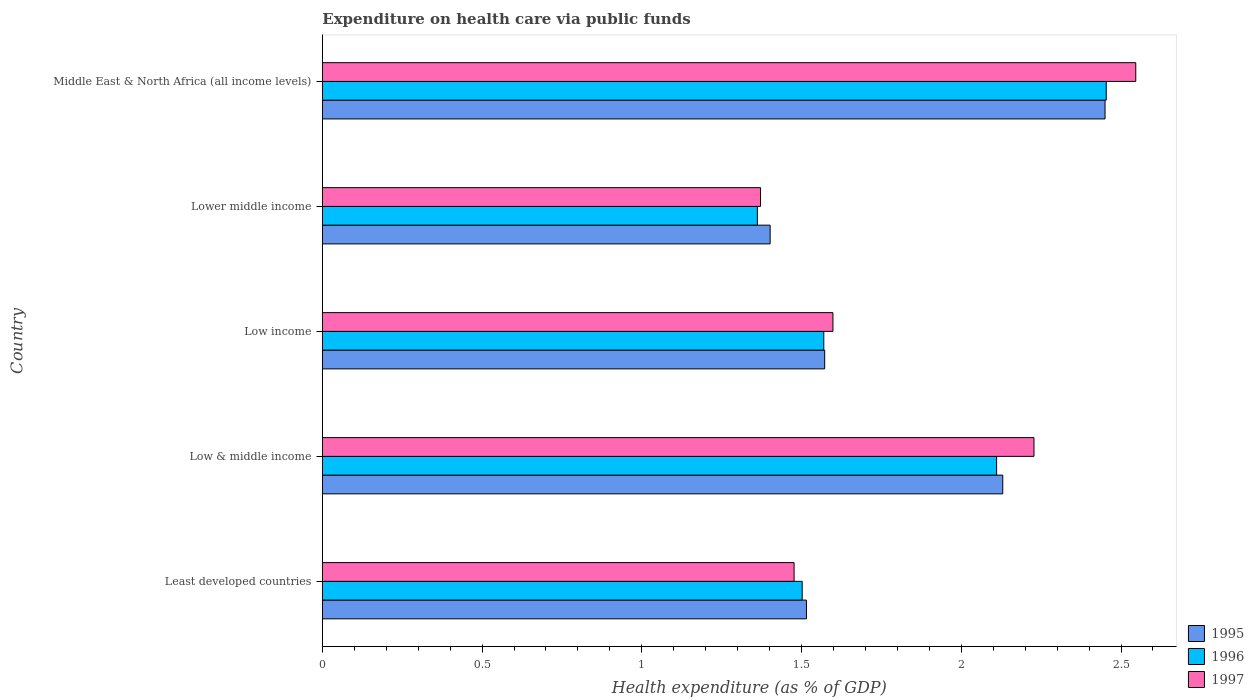Are the number of bars per tick equal to the number of legend labels?
Offer a very short reply. Yes. Are the number of bars on each tick of the Y-axis equal?
Provide a short and direct response. Yes. How many bars are there on the 3rd tick from the bottom?
Provide a succinct answer. 3. What is the label of the 2nd group of bars from the top?
Provide a short and direct response. Lower middle income. What is the expenditure made on health care in 1995 in Middle East & North Africa (all income levels)?
Give a very brief answer. 2.45. Across all countries, what is the maximum expenditure made on health care in 1995?
Your answer should be compact. 2.45. Across all countries, what is the minimum expenditure made on health care in 1996?
Your response must be concise. 1.36. In which country was the expenditure made on health care in 1995 maximum?
Give a very brief answer. Middle East & North Africa (all income levels). In which country was the expenditure made on health care in 1995 minimum?
Your answer should be very brief. Lower middle income. What is the total expenditure made on health care in 1995 in the graph?
Offer a terse response. 9.07. What is the difference between the expenditure made on health care in 1996 in Low income and that in Middle East & North Africa (all income levels)?
Offer a terse response. -0.88. What is the difference between the expenditure made on health care in 1996 in Lower middle income and the expenditure made on health care in 1995 in Least developed countries?
Provide a short and direct response. -0.15. What is the average expenditure made on health care in 1996 per country?
Keep it short and to the point. 1.8. What is the difference between the expenditure made on health care in 1996 and expenditure made on health care in 1995 in Low & middle income?
Provide a short and direct response. -0.02. What is the ratio of the expenditure made on health care in 1995 in Least developed countries to that in Middle East & North Africa (all income levels)?
Ensure brevity in your answer.  0.62. Is the expenditure made on health care in 1997 in Least developed countries less than that in Low income?
Keep it short and to the point. Yes. What is the difference between the highest and the second highest expenditure made on health care in 1996?
Your answer should be compact. 0.34. What is the difference between the highest and the lowest expenditure made on health care in 1997?
Your answer should be very brief. 1.17. In how many countries, is the expenditure made on health care in 1995 greater than the average expenditure made on health care in 1995 taken over all countries?
Your response must be concise. 2. What does the 3rd bar from the top in Least developed countries represents?
Offer a terse response. 1995. What does the 3rd bar from the bottom in Low & middle income represents?
Your answer should be compact. 1997. Is it the case that in every country, the sum of the expenditure made on health care in 1996 and expenditure made on health care in 1995 is greater than the expenditure made on health care in 1997?
Provide a succinct answer. Yes. How many bars are there?
Keep it short and to the point. 15. Are all the bars in the graph horizontal?
Ensure brevity in your answer.  Yes. How many countries are there in the graph?
Your answer should be compact. 5. Are the values on the major ticks of X-axis written in scientific E-notation?
Your answer should be compact. No. Does the graph contain grids?
Offer a terse response. No. How are the legend labels stacked?
Your answer should be very brief. Vertical. What is the title of the graph?
Your answer should be compact. Expenditure on health care via public funds. What is the label or title of the X-axis?
Your answer should be very brief. Health expenditure (as % of GDP). What is the label or title of the Y-axis?
Provide a succinct answer. Country. What is the Health expenditure (as % of GDP) in 1995 in Least developed countries?
Offer a terse response. 1.52. What is the Health expenditure (as % of GDP) of 1996 in Least developed countries?
Your answer should be compact. 1.5. What is the Health expenditure (as % of GDP) of 1997 in Least developed countries?
Provide a succinct answer. 1.48. What is the Health expenditure (as % of GDP) in 1995 in Low & middle income?
Provide a short and direct response. 2.13. What is the Health expenditure (as % of GDP) in 1996 in Low & middle income?
Ensure brevity in your answer.  2.11. What is the Health expenditure (as % of GDP) of 1997 in Low & middle income?
Your answer should be very brief. 2.23. What is the Health expenditure (as % of GDP) of 1995 in Low income?
Give a very brief answer. 1.57. What is the Health expenditure (as % of GDP) of 1996 in Low income?
Offer a terse response. 1.57. What is the Health expenditure (as % of GDP) of 1997 in Low income?
Provide a succinct answer. 1.6. What is the Health expenditure (as % of GDP) of 1995 in Lower middle income?
Your response must be concise. 1.4. What is the Health expenditure (as % of GDP) of 1996 in Lower middle income?
Ensure brevity in your answer.  1.36. What is the Health expenditure (as % of GDP) of 1997 in Lower middle income?
Give a very brief answer. 1.37. What is the Health expenditure (as % of GDP) of 1995 in Middle East & North Africa (all income levels)?
Ensure brevity in your answer.  2.45. What is the Health expenditure (as % of GDP) of 1996 in Middle East & North Africa (all income levels)?
Your answer should be compact. 2.45. What is the Health expenditure (as % of GDP) in 1997 in Middle East & North Africa (all income levels)?
Offer a terse response. 2.55. Across all countries, what is the maximum Health expenditure (as % of GDP) in 1995?
Ensure brevity in your answer.  2.45. Across all countries, what is the maximum Health expenditure (as % of GDP) in 1996?
Your response must be concise. 2.45. Across all countries, what is the maximum Health expenditure (as % of GDP) in 1997?
Provide a succinct answer. 2.55. Across all countries, what is the minimum Health expenditure (as % of GDP) of 1995?
Keep it short and to the point. 1.4. Across all countries, what is the minimum Health expenditure (as % of GDP) of 1996?
Offer a terse response. 1.36. Across all countries, what is the minimum Health expenditure (as % of GDP) of 1997?
Your answer should be compact. 1.37. What is the total Health expenditure (as % of GDP) of 1995 in the graph?
Keep it short and to the point. 9.07. What is the total Health expenditure (as % of GDP) of 1996 in the graph?
Your response must be concise. 9. What is the total Health expenditure (as % of GDP) in 1997 in the graph?
Give a very brief answer. 9.22. What is the difference between the Health expenditure (as % of GDP) in 1995 in Least developed countries and that in Low & middle income?
Ensure brevity in your answer.  -0.61. What is the difference between the Health expenditure (as % of GDP) of 1996 in Least developed countries and that in Low & middle income?
Provide a succinct answer. -0.61. What is the difference between the Health expenditure (as % of GDP) of 1997 in Least developed countries and that in Low & middle income?
Ensure brevity in your answer.  -0.75. What is the difference between the Health expenditure (as % of GDP) in 1995 in Least developed countries and that in Low income?
Keep it short and to the point. -0.06. What is the difference between the Health expenditure (as % of GDP) in 1996 in Least developed countries and that in Low income?
Your response must be concise. -0.07. What is the difference between the Health expenditure (as % of GDP) in 1997 in Least developed countries and that in Low income?
Give a very brief answer. -0.12. What is the difference between the Health expenditure (as % of GDP) in 1995 in Least developed countries and that in Lower middle income?
Keep it short and to the point. 0.11. What is the difference between the Health expenditure (as % of GDP) of 1996 in Least developed countries and that in Lower middle income?
Provide a short and direct response. 0.14. What is the difference between the Health expenditure (as % of GDP) in 1997 in Least developed countries and that in Lower middle income?
Give a very brief answer. 0.11. What is the difference between the Health expenditure (as % of GDP) in 1995 in Least developed countries and that in Middle East & North Africa (all income levels)?
Offer a very short reply. -0.93. What is the difference between the Health expenditure (as % of GDP) of 1996 in Least developed countries and that in Middle East & North Africa (all income levels)?
Provide a succinct answer. -0.95. What is the difference between the Health expenditure (as % of GDP) in 1997 in Least developed countries and that in Middle East & North Africa (all income levels)?
Provide a succinct answer. -1.07. What is the difference between the Health expenditure (as % of GDP) in 1995 in Low & middle income and that in Low income?
Offer a terse response. 0.56. What is the difference between the Health expenditure (as % of GDP) of 1996 in Low & middle income and that in Low income?
Offer a terse response. 0.54. What is the difference between the Health expenditure (as % of GDP) of 1997 in Low & middle income and that in Low income?
Your answer should be compact. 0.63. What is the difference between the Health expenditure (as % of GDP) in 1995 in Low & middle income and that in Lower middle income?
Offer a very short reply. 0.73. What is the difference between the Health expenditure (as % of GDP) of 1996 in Low & middle income and that in Lower middle income?
Ensure brevity in your answer.  0.75. What is the difference between the Health expenditure (as % of GDP) in 1997 in Low & middle income and that in Lower middle income?
Provide a short and direct response. 0.86. What is the difference between the Health expenditure (as % of GDP) in 1995 in Low & middle income and that in Middle East & North Africa (all income levels)?
Give a very brief answer. -0.32. What is the difference between the Health expenditure (as % of GDP) of 1996 in Low & middle income and that in Middle East & North Africa (all income levels)?
Offer a terse response. -0.34. What is the difference between the Health expenditure (as % of GDP) of 1997 in Low & middle income and that in Middle East & North Africa (all income levels)?
Your answer should be compact. -0.32. What is the difference between the Health expenditure (as % of GDP) of 1995 in Low income and that in Lower middle income?
Your response must be concise. 0.17. What is the difference between the Health expenditure (as % of GDP) in 1996 in Low income and that in Lower middle income?
Provide a short and direct response. 0.21. What is the difference between the Health expenditure (as % of GDP) of 1997 in Low income and that in Lower middle income?
Provide a short and direct response. 0.23. What is the difference between the Health expenditure (as % of GDP) in 1995 in Low income and that in Middle East & North Africa (all income levels)?
Make the answer very short. -0.88. What is the difference between the Health expenditure (as % of GDP) in 1996 in Low income and that in Middle East & North Africa (all income levels)?
Provide a succinct answer. -0.88. What is the difference between the Health expenditure (as % of GDP) of 1997 in Low income and that in Middle East & North Africa (all income levels)?
Your response must be concise. -0.95. What is the difference between the Health expenditure (as % of GDP) of 1995 in Lower middle income and that in Middle East & North Africa (all income levels)?
Your response must be concise. -1.05. What is the difference between the Health expenditure (as % of GDP) of 1996 in Lower middle income and that in Middle East & North Africa (all income levels)?
Provide a short and direct response. -1.09. What is the difference between the Health expenditure (as % of GDP) of 1997 in Lower middle income and that in Middle East & North Africa (all income levels)?
Provide a short and direct response. -1.17. What is the difference between the Health expenditure (as % of GDP) of 1995 in Least developed countries and the Health expenditure (as % of GDP) of 1996 in Low & middle income?
Your response must be concise. -0.6. What is the difference between the Health expenditure (as % of GDP) of 1995 in Least developed countries and the Health expenditure (as % of GDP) of 1997 in Low & middle income?
Offer a terse response. -0.71. What is the difference between the Health expenditure (as % of GDP) in 1996 in Least developed countries and the Health expenditure (as % of GDP) in 1997 in Low & middle income?
Offer a terse response. -0.73. What is the difference between the Health expenditure (as % of GDP) in 1995 in Least developed countries and the Health expenditure (as % of GDP) in 1996 in Low income?
Your answer should be compact. -0.05. What is the difference between the Health expenditure (as % of GDP) in 1995 in Least developed countries and the Health expenditure (as % of GDP) in 1997 in Low income?
Provide a succinct answer. -0.08. What is the difference between the Health expenditure (as % of GDP) of 1996 in Least developed countries and the Health expenditure (as % of GDP) of 1997 in Low income?
Your answer should be compact. -0.1. What is the difference between the Health expenditure (as % of GDP) of 1995 in Least developed countries and the Health expenditure (as % of GDP) of 1996 in Lower middle income?
Offer a very short reply. 0.15. What is the difference between the Health expenditure (as % of GDP) in 1995 in Least developed countries and the Health expenditure (as % of GDP) in 1997 in Lower middle income?
Your answer should be compact. 0.14. What is the difference between the Health expenditure (as % of GDP) in 1996 in Least developed countries and the Health expenditure (as % of GDP) in 1997 in Lower middle income?
Ensure brevity in your answer.  0.13. What is the difference between the Health expenditure (as % of GDP) in 1995 in Least developed countries and the Health expenditure (as % of GDP) in 1996 in Middle East & North Africa (all income levels)?
Offer a terse response. -0.94. What is the difference between the Health expenditure (as % of GDP) of 1995 in Least developed countries and the Health expenditure (as % of GDP) of 1997 in Middle East & North Africa (all income levels)?
Your answer should be compact. -1.03. What is the difference between the Health expenditure (as % of GDP) in 1996 in Least developed countries and the Health expenditure (as % of GDP) in 1997 in Middle East & North Africa (all income levels)?
Your answer should be very brief. -1.04. What is the difference between the Health expenditure (as % of GDP) in 1995 in Low & middle income and the Health expenditure (as % of GDP) in 1996 in Low income?
Ensure brevity in your answer.  0.56. What is the difference between the Health expenditure (as % of GDP) of 1995 in Low & middle income and the Health expenditure (as % of GDP) of 1997 in Low income?
Ensure brevity in your answer.  0.53. What is the difference between the Health expenditure (as % of GDP) in 1996 in Low & middle income and the Health expenditure (as % of GDP) in 1997 in Low income?
Your response must be concise. 0.51. What is the difference between the Health expenditure (as % of GDP) in 1995 in Low & middle income and the Health expenditure (as % of GDP) in 1996 in Lower middle income?
Provide a succinct answer. 0.77. What is the difference between the Health expenditure (as % of GDP) in 1995 in Low & middle income and the Health expenditure (as % of GDP) in 1997 in Lower middle income?
Ensure brevity in your answer.  0.76. What is the difference between the Health expenditure (as % of GDP) of 1996 in Low & middle income and the Health expenditure (as % of GDP) of 1997 in Lower middle income?
Keep it short and to the point. 0.74. What is the difference between the Health expenditure (as % of GDP) of 1995 in Low & middle income and the Health expenditure (as % of GDP) of 1996 in Middle East & North Africa (all income levels)?
Your answer should be very brief. -0.32. What is the difference between the Health expenditure (as % of GDP) of 1995 in Low & middle income and the Health expenditure (as % of GDP) of 1997 in Middle East & North Africa (all income levels)?
Provide a succinct answer. -0.42. What is the difference between the Health expenditure (as % of GDP) of 1996 in Low & middle income and the Health expenditure (as % of GDP) of 1997 in Middle East & North Africa (all income levels)?
Provide a short and direct response. -0.44. What is the difference between the Health expenditure (as % of GDP) in 1995 in Low income and the Health expenditure (as % of GDP) in 1996 in Lower middle income?
Make the answer very short. 0.21. What is the difference between the Health expenditure (as % of GDP) in 1995 in Low income and the Health expenditure (as % of GDP) in 1997 in Lower middle income?
Offer a very short reply. 0.2. What is the difference between the Health expenditure (as % of GDP) of 1996 in Low income and the Health expenditure (as % of GDP) of 1997 in Lower middle income?
Provide a short and direct response. 0.2. What is the difference between the Health expenditure (as % of GDP) of 1995 in Low income and the Health expenditure (as % of GDP) of 1996 in Middle East & North Africa (all income levels)?
Your answer should be very brief. -0.88. What is the difference between the Health expenditure (as % of GDP) in 1995 in Low income and the Health expenditure (as % of GDP) in 1997 in Middle East & North Africa (all income levels)?
Offer a very short reply. -0.97. What is the difference between the Health expenditure (as % of GDP) of 1996 in Low income and the Health expenditure (as % of GDP) of 1997 in Middle East & North Africa (all income levels)?
Keep it short and to the point. -0.98. What is the difference between the Health expenditure (as % of GDP) of 1995 in Lower middle income and the Health expenditure (as % of GDP) of 1996 in Middle East & North Africa (all income levels)?
Offer a terse response. -1.05. What is the difference between the Health expenditure (as % of GDP) in 1995 in Lower middle income and the Health expenditure (as % of GDP) in 1997 in Middle East & North Africa (all income levels)?
Your response must be concise. -1.14. What is the difference between the Health expenditure (as % of GDP) of 1996 in Lower middle income and the Health expenditure (as % of GDP) of 1997 in Middle East & North Africa (all income levels)?
Your answer should be compact. -1.18. What is the average Health expenditure (as % of GDP) in 1995 per country?
Your answer should be compact. 1.81. What is the average Health expenditure (as % of GDP) of 1996 per country?
Offer a very short reply. 1.8. What is the average Health expenditure (as % of GDP) of 1997 per country?
Offer a very short reply. 1.84. What is the difference between the Health expenditure (as % of GDP) in 1995 and Health expenditure (as % of GDP) in 1996 in Least developed countries?
Ensure brevity in your answer.  0.01. What is the difference between the Health expenditure (as % of GDP) of 1995 and Health expenditure (as % of GDP) of 1997 in Least developed countries?
Provide a succinct answer. 0.04. What is the difference between the Health expenditure (as % of GDP) in 1996 and Health expenditure (as % of GDP) in 1997 in Least developed countries?
Offer a terse response. 0.03. What is the difference between the Health expenditure (as % of GDP) in 1995 and Health expenditure (as % of GDP) in 1996 in Low & middle income?
Ensure brevity in your answer.  0.02. What is the difference between the Health expenditure (as % of GDP) of 1995 and Health expenditure (as % of GDP) of 1997 in Low & middle income?
Provide a succinct answer. -0.1. What is the difference between the Health expenditure (as % of GDP) in 1996 and Health expenditure (as % of GDP) in 1997 in Low & middle income?
Offer a terse response. -0.12. What is the difference between the Health expenditure (as % of GDP) in 1995 and Health expenditure (as % of GDP) in 1996 in Low income?
Offer a terse response. 0. What is the difference between the Health expenditure (as % of GDP) in 1995 and Health expenditure (as % of GDP) in 1997 in Low income?
Give a very brief answer. -0.03. What is the difference between the Health expenditure (as % of GDP) of 1996 and Health expenditure (as % of GDP) of 1997 in Low income?
Keep it short and to the point. -0.03. What is the difference between the Health expenditure (as % of GDP) in 1995 and Health expenditure (as % of GDP) in 1997 in Lower middle income?
Make the answer very short. 0.03. What is the difference between the Health expenditure (as % of GDP) of 1996 and Health expenditure (as % of GDP) of 1997 in Lower middle income?
Offer a very short reply. -0.01. What is the difference between the Health expenditure (as % of GDP) in 1995 and Health expenditure (as % of GDP) in 1996 in Middle East & North Africa (all income levels)?
Your response must be concise. -0. What is the difference between the Health expenditure (as % of GDP) of 1995 and Health expenditure (as % of GDP) of 1997 in Middle East & North Africa (all income levels)?
Your answer should be very brief. -0.1. What is the difference between the Health expenditure (as % of GDP) of 1996 and Health expenditure (as % of GDP) of 1997 in Middle East & North Africa (all income levels)?
Your response must be concise. -0.09. What is the ratio of the Health expenditure (as % of GDP) of 1995 in Least developed countries to that in Low & middle income?
Your response must be concise. 0.71. What is the ratio of the Health expenditure (as % of GDP) in 1996 in Least developed countries to that in Low & middle income?
Provide a succinct answer. 0.71. What is the ratio of the Health expenditure (as % of GDP) in 1997 in Least developed countries to that in Low & middle income?
Provide a short and direct response. 0.66. What is the ratio of the Health expenditure (as % of GDP) of 1995 in Least developed countries to that in Low income?
Offer a terse response. 0.96. What is the ratio of the Health expenditure (as % of GDP) of 1996 in Least developed countries to that in Low income?
Provide a succinct answer. 0.96. What is the ratio of the Health expenditure (as % of GDP) of 1997 in Least developed countries to that in Low income?
Offer a terse response. 0.92. What is the ratio of the Health expenditure (as % of GDP) of 1995 in Least developed countries to that in Lower middle income?
Make the answer very short. 1.08. What is the ratio of the Health expenditure (as % of GDP) in 1996 in Least developed countries to that in Lower middle income?
Offer a terse response. 1.1. What is the ratio of the Health expenditure (as % of GDP) of 1997 in Least developed countries to that in Lower middle income?
Provide a short and direct response. 1.08. What is the ratio of the Health expenditure (as % of GDP) of 1995 in Least developed countries to that in Middle East & North Africa (all income levels)?
Ensure brevity in your answer.  0.62. What is the ratio of the Health expenditure (as % of GDP) of 1996 in Least developed countries to that in Middle East & North Africa (all income levels)?
Keep it short and to the point. 0.61. What is the ratio of the Health expenditure (as % of GDP) in 1997 in Least developed countries to that in Middle East & North Africa (all income levels)?
Provide a short and direct response. 0.58. What is the ratio of the Health expenditure (as % of GDP) of 1995 in Low & middle income to that in Low income?
Offer a very short reply. 1.35. What is the ratio of the Health expenditure (as % of GDP) in 1996 in Low & middle income to that in Low income?
Keep it short and to the point. 1.34. What is the ratio of the Health expenditure (as % of GDP) of 1997 in Low & middle income to that in Low income?
Your answer should be compact. 1.39. What is the ratio of the Health expenditure (as % of GDP) of 1995 in Low & middle income to that in Lower middle income?
Your answer should be compact. 1.52. What is the ratio of the Health expenditure (as % of GDP) in 1996 in Low & middle income to that in Lower middle income?
Offer a very short reply. 1.55. What is the ratio of the Health expenditure (as % of GDP) in 1997 in Low & middle income to that in Lower middle income?
Offer a terse response. 1.62. What is the ratio of the Health expenditure (as % of GDP) of 1995 in Low & middle income to that in Middle East & North Africa (all income levels)?
Provide a short and direct response. 0.87. What is the ratio of the Health expenditure (as % of GDP) in 1996 in Low & middle income to that in Middle East & North Africa (all income levels)?
Offer a very short reply. 0.86. What is the ratio of the Health expenditure (as % of GDP) in 1997 in Low & middle income to that in Middle East & North Africa (all income levels)?
Provide a short and direct response. 0.87. What is the ratio of the Health expenditure (as % of GDP) in 1995 in Low income to that in Lower middle income?
Your response must be concise. 1.12. What is the ratio of the Health expenditure (as % of GDP) of 1996 in Low income to that in Lower middle income?
Provide a short and direct response. 1.15. What is the ratio of the Health expenditure (as % of GDP) in 1997 in Low income to that in Lower middle income?
Your response must be concise. 1.17. What is the ratio of the Health expenditure (as % of GDP) in 1995 in Low income to that in Middle East & North Africa (all income levels)?
Ensure brevity in your answer.  0.64. What is the ratio of the Health expenditure (as % of GDP) in 1996 in Low income to that in Middle East & North Africa (all income levels)?
Give a very brief answer. 0.64. What is the ratio of the Health expenditure (as % of GDP) of 1997 in Low income to that in Middle East & North Africa (all income levels)?
Make the answer very short. 0.63. What is the ratio of the Health expenditure (as % of GDP) in 1995 in Lower middle income to that in Middle East & North Africa (all income levels)?
Provide a short and direct response. 0.57. What is the ratio of the Health expenditure (as % of GDP) of 1996 in Lower middle income to that in Middle East & North Africa (all income levels)?
Your answer should be very brief. 0.55. What is the ratio of the Health expenditure (as % of GDP) of 1997 in Lower middle income to that in Middle East & North Africa (all income levels)?
Your answer should be compact. 0.54. What is the difference between the highest and the second highest Health expenditure (as % of GDP) in 1995?
Your response must be concise. 0.32. What is the difference between the highest and the second highest Health expenditure (as % of GDP) of 1996?
Ensure brevity in your answer.  0.34. What is the difference between the highest and the second highest Health expenditure (as % of GDP) of 1997?
Your response must be concise. 0.32. What is the difference between the highest and the lowest Health expenditure (as % of GDP) of 1995?
Your answer should be compact. 1.05. What is the difference between the highest and the lowest Health expenditure (as % of GDP) of 1996?
Provide a succinct answer. 1.09. What is the difference between the highest and the lowest Health expenditure (as % of GDP) in 1997?
Make the answer very short. 1.17. 